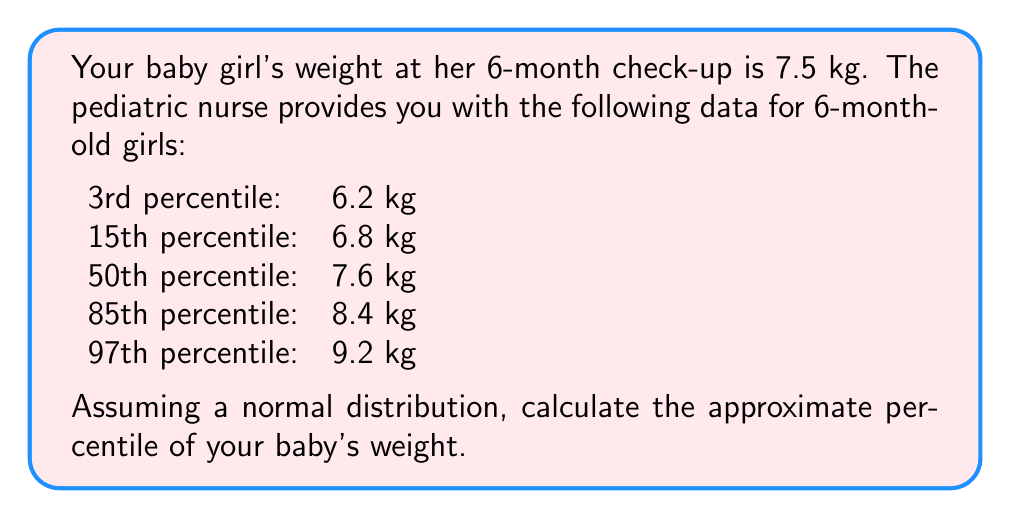What is the answer to this math problem? To find the approximate percentile for your baby's weight, we'll use the z-score method and the properties of the normal distribution. Here's how to proceed:

1) First, we need to estimate the mean (μ) and standard deviation (σ) of the distribution. We can use the 50th percentile as the mean:

   μ = 7.6 kg

2) To estimate σ, we can use the property that approximately 95% of data falls within 2σ of the mean in a normal distribution. The 3rd and 97th percentiles are close to this range:

   $$(9.2 - 6.2) / 4 ≈ σ$$
   $$σ ≈ 0.75 kg$$

3) Now, calculate the z-score for your baby's weight:

   $$z = \frac{x - μ}{σ} = \frac{7.5 - 7.6}{0.75} = -0.1333$$

4) To convert this z-score to a percentile, we need to use a standard normal distribution table or a calculator. The area to the left of z = -0.1333 is approximately 0.4470.

5) Convert this area to a percentile:

   Percentile = 0.4470 * 100 ≈ 44.70%

Therefore, your baby's weight is approximately at the 45th percentile.
Answer: 45th percentile 